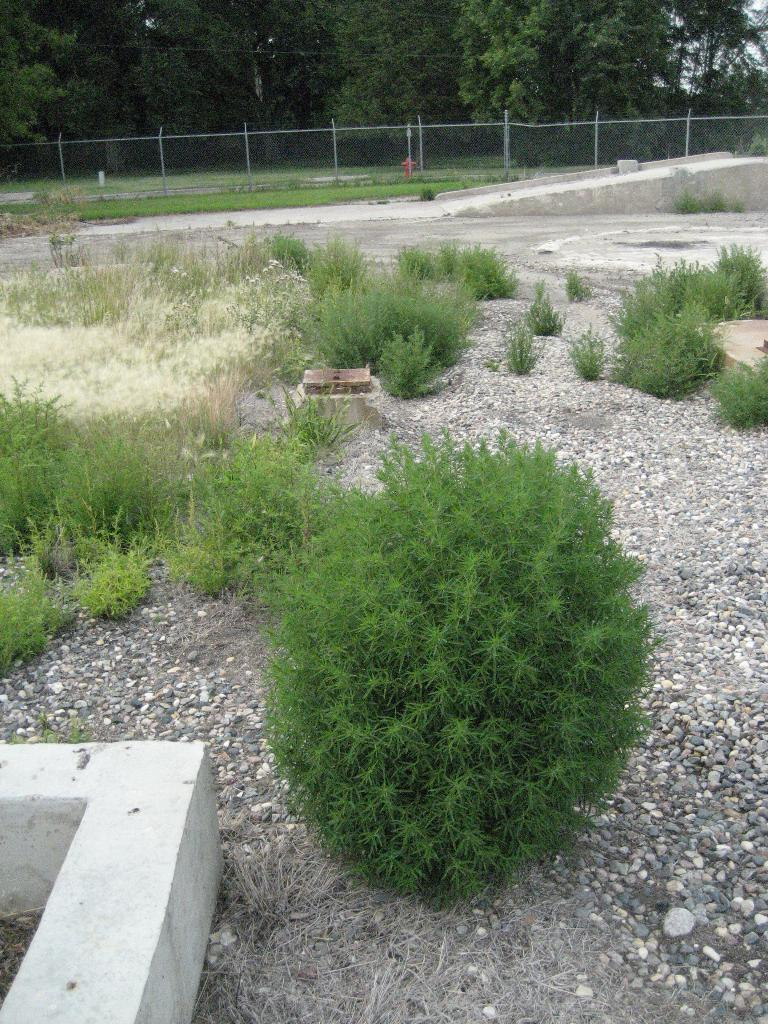What type of living organisms can be seen in the image? Plants can be seen in the image. What other objects are present in the image? There are stones visible in the image. What can be seen in the background of the image? Fencing, a fire hydrant, and trees can be seen in the background of the image. How many chairs are visible in the image? There are no chairs present in the image. What type of knife can be seen in the image? There is no knife present in the image. 